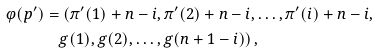Convert formula to latex. <formula><loc_0><loc_0><loc_500><loc_500>\varphi ( p ^ { \prime } ) & = ( \pi ^ { \prime } ( 1 ) + n - i , \pi ^ { \prime } ( 2 ) + n - i , \dots , \pi ^ { \prime } ( i ) + n - i , \\ & \quad g ( 1 ) , g ( 2 ) , \dots , g ( n + 1 - i ) ) \, ,</formula> 